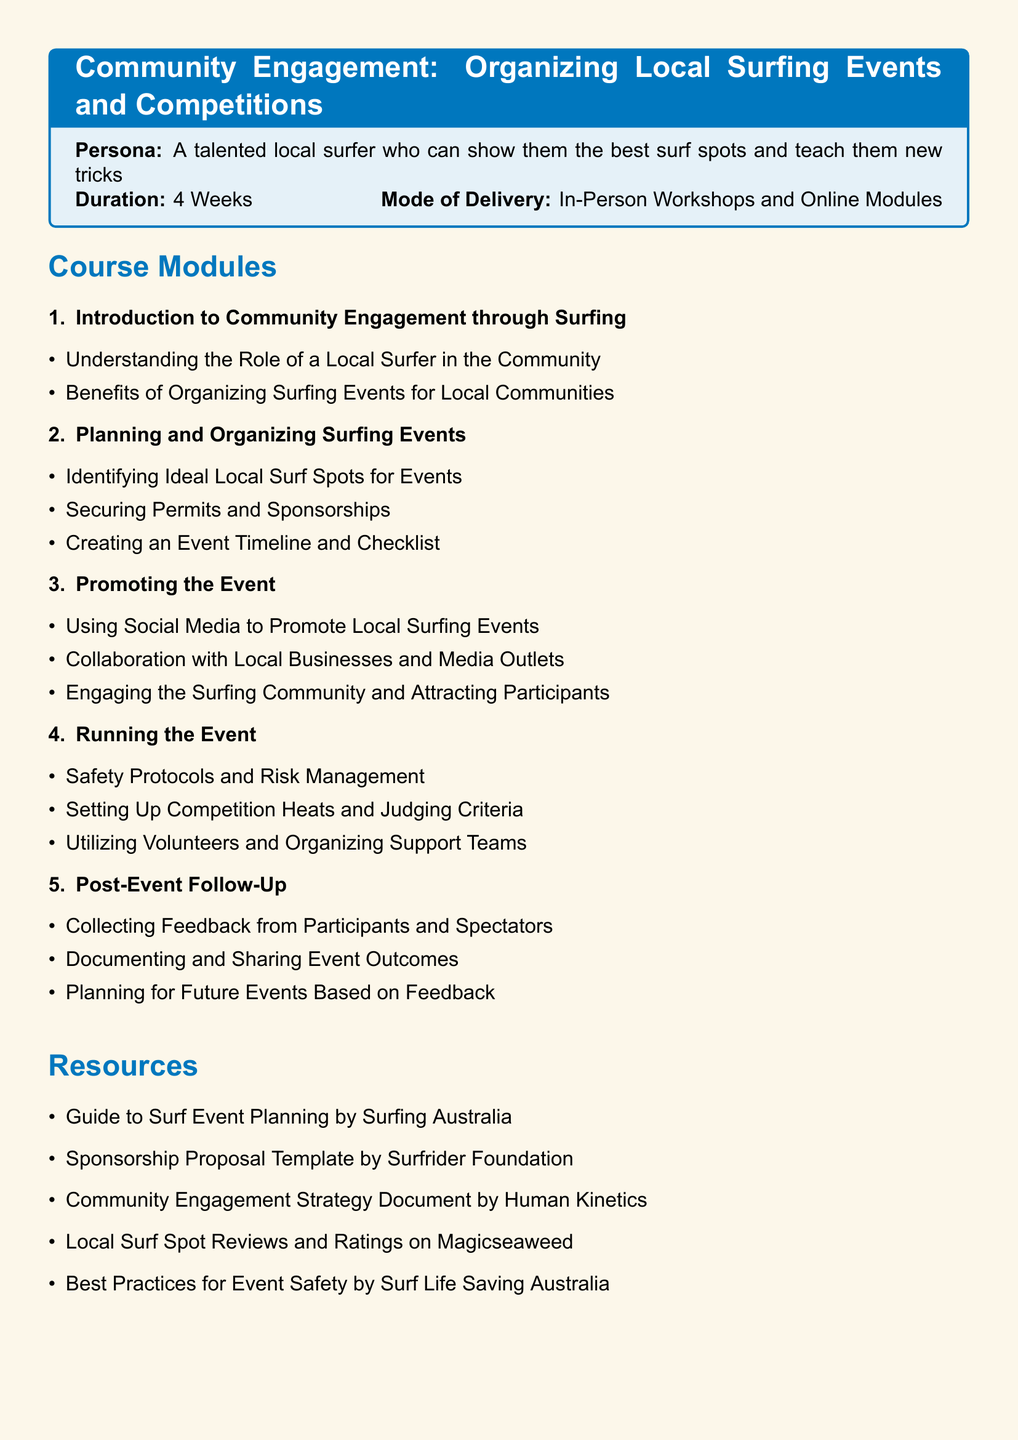What is the duration of the course? The duration of the course is explicitly stated in the syllabus as 4 Weeks.
Answer: 4 Weeks What is the mode of delivery? The document specifies that the course is delivered through In-Person Workshops and Online Modules.
Answer: In-Person Workshops and Online Modules What is the first module titled? The first module of the course is titled "Introduction to Community Engagement through Surfing."
Answer: Introduction to Community Engagement through Surfing Which resource is mentioned for best practices in event safety? The syllabus lists "Best Practices for Event Safety by Surf Life Saving Australia" as a resource.
Answer: Best Practices for Event Safety by Surf Life Saving Australia What is the final project requirement? The final project requirement is to "Organize a Mini Surfing Event," according to the assessment methods in the syllabus.
Answer: Organize a Mini Surfing Event How many main modules are there in the syllabus? Counting the listed modules reveals that there are five main modules in the syllabus.
Answer: 5 Which item covers community engagement strategies? The "Community Engagement Strategy Document by Human Kinetics" is indicated as a resource for community engagement strategies.
Answer: Community Engagement Strategy Document by Human Kinetics What must be collected from participants after the event? The document states that feedback must be collected from participants and spectators after the event.
Answer: Feedback from Participants and Spectators 